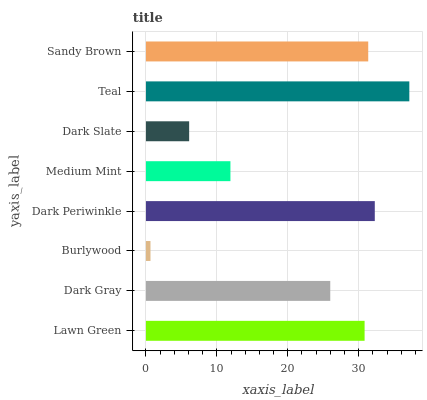Is Burlywood the minimum?
Answer yes or no. Yes. Is Teal the maximum?
Answer yes or no. Yes. Is Dark Gray the minimum?
Answer yes or no. No. Is Dark Gray the maximum?
Answer yes or no. No. Is Lawn Green greater than Dark Gray?
Answer yes or no. Yes. Is Dark Gray less than Lawn Green?
Answer yes or no. Yes. Is Dark Gray greater than Lawn Green?
Answer yes or no. No. Is Lawn Green less than Dark Gray?
Answer yes or no. No. Is Lawn Green the high median?
Answer yes or no. Yes. Is Dark Gray the low median?
Answer yes or no. Yes. Is Dark Periwinkle the high median?
Answer yes or no. No. Is Dark Slate the low median?
Answer yes or no. No. 